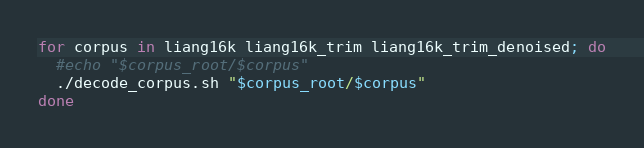Convert code to text. <code><loc_0><loc_0><loc_500><loc_500><_Bash_>
for corpus in liang16k liang16k_trim liang16k_trim_denoised; do
  #echo "$corpus_root/$corpus"
  ./decode_corpus.sh "$corpus_root/$corpus"
done
</code> 